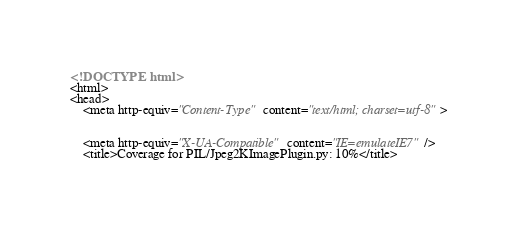<code> <loc_0><loc_0><loc_500><loc_500><_HTML_>


<!DOCTYPE html>
<html>
<head>
    <meta http-equiv="Content-Type" content="text/html; charset=utf-8">
    
    
    <meta http-equiv="X-UA-Compatible" content="IE=emulateIE7" />
    <title>Coverage for PIL/Jpeg2KImagePlugin.py: 10%</title></code> 